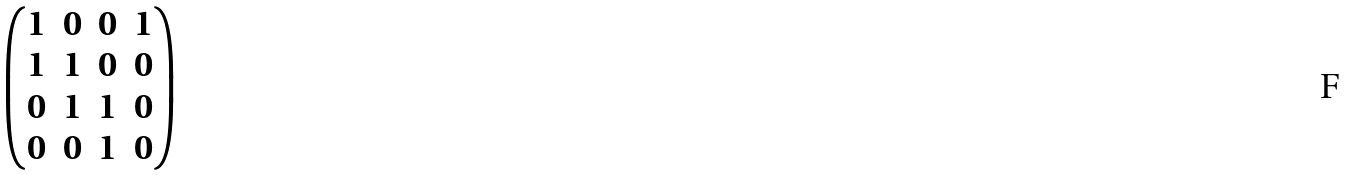Convert formula to latex. <formula><loc_0><loc_0><loc_500><loc_500>\begin{pmatrix} 1 & 0 & 0 & 1 \\ 1 & 1 & 0 & 0 \\ 0 & 1 & 1 & 0 \\ 0 & 0 & 1 & 0 \end{pmatrix}</formula> 